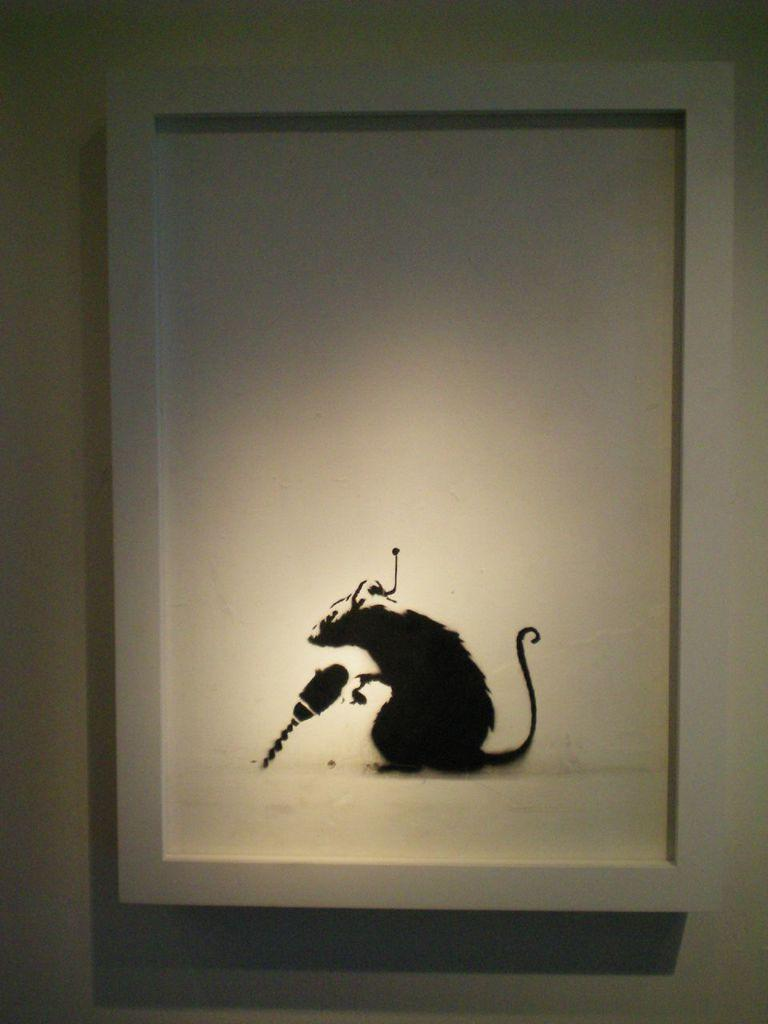What object is visible in the image that typically holds a picture? There is a photo frame in the image. Where is the photo frame located? The photo frame is on a wall. What is depicted in the photo frame? The photo frame contains a picture of a rat. What type of cherries are being served in the lunchroom in the image? There is no mention of cherries or a lunchroom in the image; it only features a photo frame with a picture of a rat. 